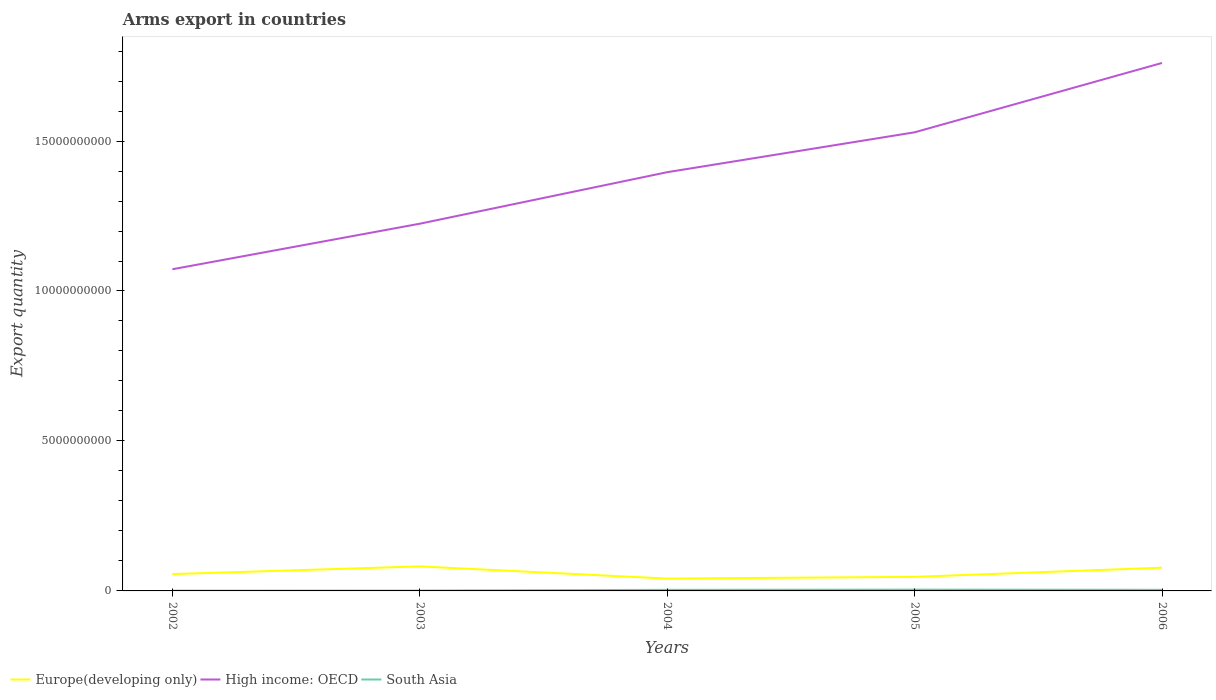How many different coloured lines are there?
Provide a short and direct response. 3. Is the number of lines equal to the number of legend labels?
Your response must be concise. Yes. Across all years, what is the maximum total arms export in High income: OECD?
Keep it short and to the point. 1.07e+1. In which year was the total arms export in South Asia maximum?
Provide a short and direct response. 2002. What is the total total arms export in Europe(developing only) in the graph?
Your response must be concise. -2.13e+08. What is the difference between the highest and the second highest total arms export in High income: OECD?
Keep it short and to the point. 6.88e+09. How many years are there in the graph?
Offer a very short reply. 5. Are the values on the major ticks of Y-axis written in scientific E-notation?
Your response must be concise. No. How many legend labels are there?
Make the answer very short. 3. How are the legend labels stacked?
Ensure brevity in your answer.  Horizontal. What is the title of the graph?
Make the answer very short. Arms export in countries. Does "High income" appear as one of the legend labels in the graph?
Keep it short and to the point. No. What is the label or title of the Y-axis?
Ensure brevity in your answer.  Export quantity. What is the Export quantity in Europe(developing only) in 2002?
Your response must be concise. 5.61e+08. What is the Export quantity in High income: OECD in 2002?
Keep it short and to the point. 1.07e+1. What is the Export quantity of South Asia in 2002?
Offer a very short reply. 9.00e+06. What is the Export quantity of Europe(developing only) in 2003?
Your response must be concise. 8.18e+08. What is the Export quantity in High income: OECD in 2003?
Your answer should be compact. 1.22e+1. What is the Export quantity in Europe(developing only) in 2004?
Provide a succinct answer. 4.11e+08. What is the Export quantity of High income: OECD in 2004?
Keep it short and to the point. 1.40e+1. What is the Export quantity of South Asia in 2004?
Provide a short and direct response. 3.60e+07. What is the Export quantity in Europe(developing only) in 2005?
Keep it short and to the point. 4.69e+08. What is the Export quantity of High income: OECD in 2005?
Offer a terse response. 1.53e+1. What is the Export quantity of South Asia in 2005?
Provide a short and direct response. 4.30e+07. What is the Export quantity of Europe(developing only) in 2006?
Your answer should be compact. 7.74e+08. What is the Export quantity in High income: OECD in 2006?
Provide a succinct answer. 1.76e+1. What is the Export quantity of South Asia in 2006?
Your answer should be compact. 3.70e+07. Across all years, what is the maximum Export quantity of Europe(developing only)?
Offer a very short reply. 8.18e+08. Across all years, what is the maximum Export quantity of High income: OECD?
Offer a terse response. 1.76e+1. Across all years, what is the maximum Export quantity of South Asia?
Your answer should be compact. 4.30e+07. Across all years, what is the minimum Export quantity of Europe(developing only)?
Keep it short and to the point. 4.11e+08. Across all years, what is the minimum Export quantity in High income: OECD?
Your answer should be compact. 1.07e+1. Across all years, what is the minimum Export quantity in South Asia?
Provide a succinct answer. 9.00e+06. What is the total Export quantity in Europe(developing only) in the graph?
Make the answer very short. 3.03e+09. What is the total Export quantity in High income: OECD in the graph?
Your answer should be very brief. 6.98e+1. What is the total Export quantity of South Asia in the graph?
Give a very brief answer. 1.37e+08. What is the difference between the Export quantity in Europe(developing only) in 2002 and that in 2003?
Offer a terse response. -2.57e+08. What is the difference between the Export quantity of High income: OECD in 2002 and that in 2003?
Your answer should be very brief. -1.52e+09. What is the difference between the Export quantity of Europe(developing only) in 2002 and that in 2004?
Keep it short and to the point. 1.50e+08. What is the difference between the Export quantity of High income: OECD in 2002 and that in 2004?
Offer a terse response. -3.24e+09. What is the difference between the Export quantity in South Asia in 2002 and that in 2004?
Give a very brief answer. -2.70e+07. What is the difference between the Export quantity of Europe(developing only) in 2002 and that in 2005?
Offer a very short reply. 9.20e+07. What is the difference between the Export quantity of High income: OECD in 2002 and that in 2005?
Offer a terse response. -4.57e+09. What is the difference between the Export quantity of South Asia in 2002 and that in 2005?
Your answer should be compact. -3.40e+07. What is the difference between the Export quantity in Europe(developing only) in 2002 and that in 2006?
Your answer should be very brief. -2.13e+08. What is the difference between the Export quantity of High income: OECD in 2002 and that in 2006?
Offer a very short reply. -6.88e+09. What is the difference between the Export quantity in South Asia in 2002 and that in 2006?
Provide a short and direct response. -2.80e+07. What is the difference between the Export quantity in Europe(developing only) in 2003 and that in 2004?
Your answer should be very brief. 4.07e+08. What is the difference between the Export quantity of High income: OECD in 2003 and that in 2004?
Provide a short and direct response. -1.72e+09. What is the difference between the Export quantity of South Asia in 2003 and that in 2004?
Provide a succinct answer. -2.40e+07. What is the difference between the Export quantity of Europe(developing only) in 2003 and that in 2005?
Provide a short and direct response. 3.49e+08. What is the difference between the Export quantity of High income: OECD in 2003 and that in 2005?
Provide a succinct answer. -3.05e+09. What is the difference between the Export quantity in South Asia in 2003 and that in 2005?
Make the answer very short. -3.10e+07. What is the difference between the Export quantity of Europe(developing only) in 2003 and that in 2006?
Provide a short and direct response. 4.40e+07. What is the difference between the Export quantity in High income: OECD in 2003 and that in 2006?
Provide a succinct answer. -5.36e+09. What is the difference between the Export quantity of South Asia in 2003 and that in 2006?
Make the answer very short. -2.50e+07. What is the difference between the Export quantity in Europe(developing only) in 2004 and that in 2005?
Your answer should be compact. -5.80e+07. What is the difference between the Export quantity in High income: OECD in 2004 and that in 2005?
Make the answer very short. -1.33e+09. What is the difference between the Export quantity in South Asia in 2004 and that in 2005?
Make the answer very short. -7.00e+06. What is the difference between the Export quantity in Europe(developing only) in 2004 and that in 2006?
Offer a terse response. -3.63e+08. What is the difference between the Export quantity in High income: OECD in 2004 and that in 2006?
Offer a very short reply. -3.64e+09. What is the difference between the Export quantity of Europe(developing only) in 2005 and that in 2006?
Provide a succinct answer. -3.05e+08. What is the difference between the Export quantity of High income: OECD in 2005 and that in 2006?
Give a very brief answer. -2.31e+09. What is the difference between the Export quantity in Europe(developing only) in 2002 and the Export quantity in High income: OECD in 2003?
Your answer should be compact. -1.17e+1. What is the difference between the Export quantity in Europe(developing only) in 2002 and the Export quantity in South Asia in 2003?
Your answer should be compact. 5.49e+08. What is the difference between the Export quantity in High income: OECD in 2002 and the Export quantity in South Asia in 2003?
Keep it short and to the point. 1.07e+1. What is the difference between the Export quantity in Europe(developing only) in 2002 and the Export quantity in High income: OECD in 2004?
Keep it short and to the point. -1.34e+1. What is the difference between the Export quantity of Europe(developing only) in 2002 and the Export quantity of South Asia in 2004?
Offer a very short reply. 5.25e+08. What is the difference between the Export quantity of High income: OECD in 2002 and the Export quantity of South Asia in 2004?
Your answer should be compact. 1.07e+1. What is the difference between the Export quantity of Europe(developing only) in 2002 and the Export quantity of High income: OECD in 2005?
Offer a very short reply. -1.47e+1. What is the difference between the Export quantity of Europe(developing only) in 2002 and the Export quantity of South Asia in 2005?
Make the answer very short. 5.18e+08. What is the difference between the Export quantity of High income: OECD in 2002 and the Export quantity of South Asia in 2005?
Provide a succinct answer. 1.07e+1. What is the difference between the Export quantity of Europe(developing only) in 2002 and the Export quantity of High income: OECD in 2006?
Keep it short and to the point. -1.70e+1. What is the difference between the Export quantity of Europe(developing only) in 2002 and the Export quantity of South Asia in 2006?
Provide a succinct answer. 5.24e+08. What is the difference between the Export quantity in High income: OECD in 2002 and the Export quantity in South Asia in 2006?
Give a very brief answer. 1.07e+1. What is the difference between the Export quantity of Europe(developing only) in 2003 and the Export quantity of High income: OECD in 2004?
Give a very brief answer. -1.31e+1. What is the difference between the Export quantity of Europe(developing only) in 2003 and the Export quantity of South Asia in 2004?
Your response must be concise. 7.82e+08. What is the difference between the Export quantity of High income: OECD in 2003 and the Export quantity of South Asia in 2004?
Keep it short and to the point. 1.22e+1. What is the difference between the Export quantity of Europe(developing only) in 2003 and the Export quantity of High income: OECD in 2005?
Your answer should be compact. -1.45e+1. What is the difference between the Export quantity in Europe(developing only) in 2003 and the Export quantity in South Asia in 2005?
Your answer should be compact. 7.75e+08. What is the difference between the Export quantity in High income: OECD in 2003 and the Export quantity in South Asia in 2005?
Provide a short and direct response. 1.22e+1. What is the difference between the Export quantity of Europe(developing only) in 2003 and the Export quantity of High income: OECD in 2006?
Offer a very short reply. -1.68e+1. What is the difference between the Export quantity of Europe(developing only) in 2003 and the Export quantity of South Asia in 2006?
Make the answer very short. 7.81e+08. What is the difference between the Export quantity in High income: OECD in 2003 and the Export quantity in South Asia in 2006?
Give a very brief answer. 1.22e+1. What is the difference between the Export quantity in Europe(developing only) in 2004 and the Export quantity in High income: OECD in 2005?
Keep it short and to the point. -1.49e+1. What is the difference between the Export quantity of Europe(developing only) in 2004 and the Export quantity of South Asia in 2005?
Give a very brief answer. 3.68e+08. What is the difference between the Export quantity in High income: OECD in 2004 and the Export quantity in South Asia in 2005?
Make the answer very short. 1.39e+1. What is the difference between the Export quantity in Europe(developing only) in 2004 and the Export quantity in High income: OECD in 2006?
Your answer should be compact. -1.72e+1. What is the difference between the Export quantity in Europe(developing only) in 2004 and the Export quantity in South Asia in 2006?
Offer a very short reply. 3.74e+08. What is the difference between the Export quantity of High income: OECD in 2004 and the Export quantity of South Asia in 2006?
Your answer should be very brief. 1.39e+1. What is the difference between the Export quantity in Europe(developing only) in 2005 and the Export quantity in High income: OECD in 2006?
Your answer should be very brief. -1.71e+1. What is the difference between the Export quantity of Europe(developing only) in 2005 and the Export quantity of South Asia in 2006?
Keep it short and to the point. 4.32e+08. What is the difference between the Export quantity of High income: OECD in 2005 and the Export quantity of South Asia in 2006?
Give a very brief answer. 1.53e+1. What is the average Export quantity of Europe(developing only) per year?
Your answer should be compact. 6.07e+08. What is the average Export quantity in High income: OECD per year?
Keep it short and to the point. 1.40e+1. What is the average Export quantity in South Asia per year?
Make the answer very short. 2.74e+07. In the year 2002, what is the difference between the Export quantity in Europe(developing only) and Export quantity in High income: OECD?
Your answer should be compact. -1.02e+1. In the year 2002, what is the difference between the Export quantity in Europe(developing only) and Export quantity in South Asia?
Your answer should be compact. 5.52e+08. In the year 2002, what is the difference between the Export quantity in High income: OECD and Export quantity in South Asia?
Provide a succinct answer. 1.07e+1. In the year 2003, what is the difference between the Export quantity of Europe(developing only) and Export quantity of High income: OECD?
Offer a very short reply. -1.14e+1. In the year 2003, what is the difference between the Export quantity of Europe(developing only) and Export quantity of South Asia?
Offer a terse response. 8.06e+08. In the year 2003, what is the difference between the Export quantity of High income: OECD and Export quantity of South Asia?
Make the answer very short. 1.22e+1. In the year 2004, what is the difference between the Export quantity of Europe(developing only) and Export quantity of High income: OECD?
Provide a short and direct response. -1.36e+1. In the year 2004, what is the difference between the Export quantity in Europe(developing only) and Export quantity in South Asia?
Your response must be concise. 3.75e+08. In the year 2004, what is the difference between the Export quantity in High income: OECD and Export quantity in South Asia?
Offer a very short reply. 1.39e+1. In the year 2005, what is the difference between the Export quantity of Europe(developing only) and Export quantity of High income: OECD?
Provide a short and direct response. -1.48e+1. In the year 2005, what is the difference between the Export quantity in Europe(developing only) and Export quantity in South Asia?
Offer a very short reply. 4.26e+08. In the year 2005, what is the difference between the Export quantity of High income: OECD and Export quantity of South Asia?
Your answer should be compact. 1.52e+1. In the year 2006, what is the difference between the Export quantity in Europe(developing only) and Export quantity in High income: OECD?
Your answer should be very brief. -1.68e+1. In the year 2006, what is the difference between the Export quantity in Europe(developing only) and Export quantity in South Asia?
Keep it short and to the point. 7.37e+08. In the year 2006, what is the difference between the Export quantity in High income: OECD and Export quantity in South Asia?
Your answer should be very brief. 1.76e+1. What is the ratio of the Export quantity in Europe(developing only) in 2002 to that in 2003?
Make the answer very short. 0.69. What is the ratio of the Export quantity of High income: OECD in 2002 to that in 2003?
Provide a succinct answer. 0.88. What is the ratio of the Export quantity in Europe(developing only) in 2002 to that in 2004?
Keep it short and to the point. 1.36. What is the ratio of the Export quantity in High income: OECD in 2002 to that in 2004?
Your response must be concise. 0.77. What is the ratio of the Export quantity in South Asia in 2002 to that in 2004?
Offer a terse response. 0.25. What is the ratio of the Export quantity of Europe(developing only) in 2002 to that in 2005?
Provide a short and direct response. 1.2. What is the ratio of the Export quantity of High income: OECD in 2002 to that in 2005?
Your answer should be compact. 0.7. What is the ratio of the Export quantity in South Asia in 2002 to that in 2005?
Offer a very short reply. 0.21. What is the ratio of the Export quantity in Europe(developing only) in 2002 to that in 2006?
Ensure brevity in your answer.  0.72. What is the ratio of the Export quantity in High income: OECD in 2002 to that in 2006?
Offer a terse response. 0.61. What is the ratio of the Export quantity of South Asia in 2002 to that in 2006?
Make the answer very short. 0.24. What is the ratio of the Export quantity of Europe(developing only) in 2003 to that in 2004?
Offer a very short reply. 1.99. What is the ratio of the Export quantity in High income: OECD in 2003 to that in 2004?
Your response must be concise. 0.88. What is the ratio of the Export quantity in Europe(developing only) in 2003 to that in 2005?
Your response must be concise. 1.74. What is the ratio of the Export quantity of High income: OECD in 2003 to that in 2005?
Your answer should be very brief. 0.8. What is the ratio of the Export quantity of South Asia in 2003 to that in 2005?
Offer a very short reply. 0.28. What is the ratio of the Export quantity of Europe(developing only) in 2003 to that in 2006?
Provide a succinct answer. 1.06. What is the ratio of the Export quantity in High income: OECD in 2003 to that in 2006?
Provide a short and direct response. 0.7. What is the ratio of the Export quantity of South Asia in 2003 to that in 2006?
Provide a short and direct response. 0.32. What is the ratio of the Export quantity of Europe(developing only) in 2004 to that in 2005?
Your response must be concise. 0.88. What is the ratio of the Export quantity of High income: OECD in 2004 to that in 2005?
Provide a short and direct response. 0.91. What is the ratio of the Export quantity in South Asia in 2004 to that in 2005?
Provide a succinct answer. 0.84. What is the ratio of the Export quantity of Europe(developing only) in 2004 to that in 2006?
Your answer should be very brief. 0.53. What is the ratio of the Export quantity of High income: OECD in 2004 to that in 2006?
Provide a short and direct response. 0.79. What is the ratio of the Export quantity of South Asia in 2004 to that in 2006?
Make the answer very short. 0.97. What is the ratio of the Export quantity of Europe(developing only) in 2005 to that in 2006?
Provide a succinct answer. 0.61. What is the ratio of the Export quantity in High income: OECD in 2005 to that in 2006?
Keep it short and to the point. 0.87. What is the ratio of the Export quantity of South Asia in 2005 to that in 2006?
Your answer should be compact. 1.16. What is the difference between the highest and the second highest Export quantity in Europe(developing only)?
Ensure brevity in your answer.  4.40e+07. What is the difference between the highest and the second highest Export quantity in High income: OECD?
Provide a succinct answer. 2.31e+09. What is the difference between the highest and the second highest Export quantity in South Asia?
Your response must be concise. 6.00e+06. What is the difference between the highest and the lowest Export quantity of Europe(developing only)?
Make the answer very short. 4.07e+08. What is the difference between the highest and the lowest Export quantity in High income: OECD?
Ensure brevity in your answer.  6.88e+09. What is the difference between the highest and the lowest Export quantity in South Asia?
Make the answer very short. 3.40e+07. 